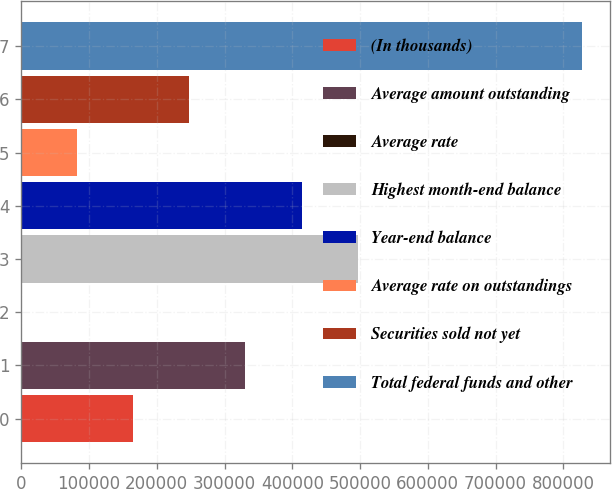Convert chart to OTSL. <chart><loc_0><loc_0><loc_500><loc_500><bar_chart><fcel>(In thousands)<fcel>Average amount outstanding<fcel>Average rate<fcel>Highest month-end balance<fcel>Year-end balance<fcel>Average rate on outstandings<fcel>Securities sold not yet<fcel>Total federal funds and other<nl><fcel>165454<fcel>330908<fcel>0.29<fcel>496362<fcel>413635<fcel>82727.2<fcel>248181<fcel>827269<nl></chart> 